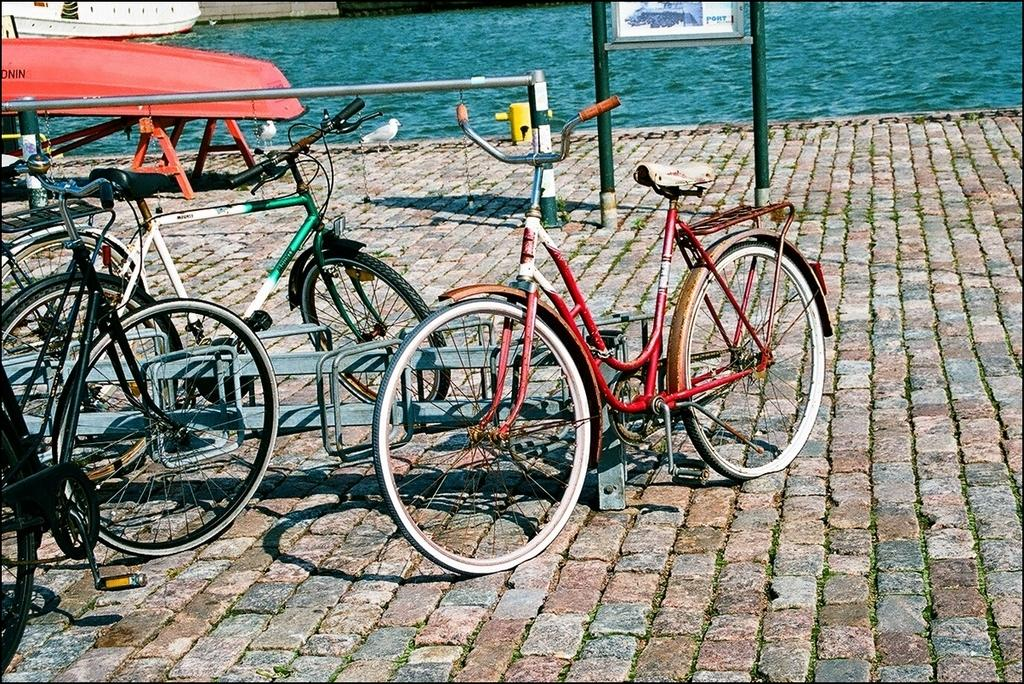What type of vehicles are present in the image? There are bicycles in the image. What is the color of the water visible in the image? The water in the image is blue-colored. What historical discovery can be seen in the image? There is no historical discovery present in the image; it features bicycles and blue-colored water. What is the altitude of the sky in the image? The sky is not present in the image, so its altitude cannot be determined. 